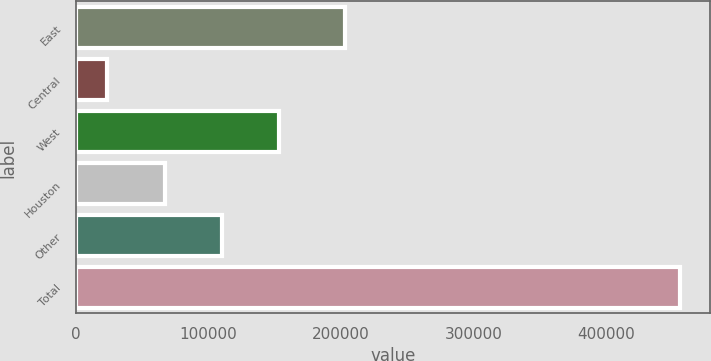Convert chart. <chart><loc_0><loc_0><loc_500><loc_500><bar_chart><fcel>East<fcel>Central<fcel>West<fcel>Houston<fcel>Other<fcel>Total<nl><fcel>202791<fcel>23736<fcel>153496<fcel>66989.4<fcel>110243<fcel>456270<nl></chart> 